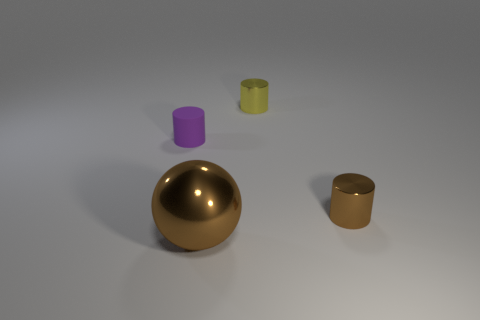How many purple matte objects have the same shape as the yellow object?
Make the answer very short. 1. What shape is the tiny metal object that is the same color as the large shiny sphere?
Provide a succinct answer. Cylinder. The purple matte thing that is the same size as the brown cylinder is what shape?
Your response must be concise. Cylinder. Are there fewer large green objects than brown cylinders?
Ensure brevity in your answer.  Yes. Are there any purple objects that are on the right side of the tiny cylinder left of the brown sphere?
Offer a terse response. No. There is a small object that is the same material as the small brown cylinder; what shape is it?
Offer a terse response. Cylinder. Is there any other thing that has the same color as the ball?
Provide a short and direct response. Yes. There is a small brown object that is the same shape as the purple matte thing; what is its material?
Provide a succinct answer. Metal. What number of other things are the same size as the yellow cylinder?
Your response must be concise. 2. What is the size of the metallic cylinder that is the same color as the sphere?
Make the answer very short. Small. 